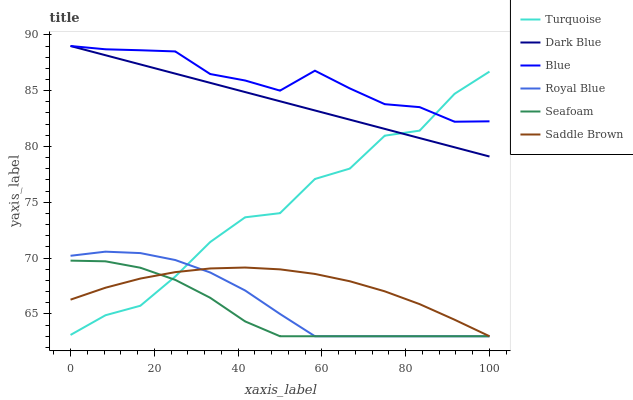Does Seafoam have the minimum area under the curve?
Answer yes or no. Yes. Does Blue have the maximum area under the curve?
Answer yes or no. Yes. Does Turquoise have the minimum area under the curve?
Answer yes or no. No. Does Turquoise have the maximum area under the curve?
Answer yes or no. No. Is Dark Blue the smoothest?
Answer yes or no. Yes. Is Turquoise the roughest?
Answer yes or no. Yes. Is Royal Blue the smoothest?
Answer yes or no. No. Is Royal Blue the roughest?
Answer yes or no. No. Does Royal Blue have the lowest value?
Answer yes or no. Yes. Does Turquoise have the lowest value?
Answer yes or no. No. Does Dark Blue have the highest value?
Answer yes or no. Yes. Does Turquoise have the highest value?
Answer yes or no. No. Is Saddle Brown less than Blue?
Answer yes or no. Yes. Is Blue greater than Seafoam?
Answer yes or no. Yes. Does Royal Blue intersect Turquoise?
Answer yes or no. Yes. Is Royal Blue less than Turquoise?
Answer yes or no. No. Is Royal Blue greater than Turquoise?
Answer yes or no. No. Does Saddle Brown intersect Blue?
Answer yes or no. No. 